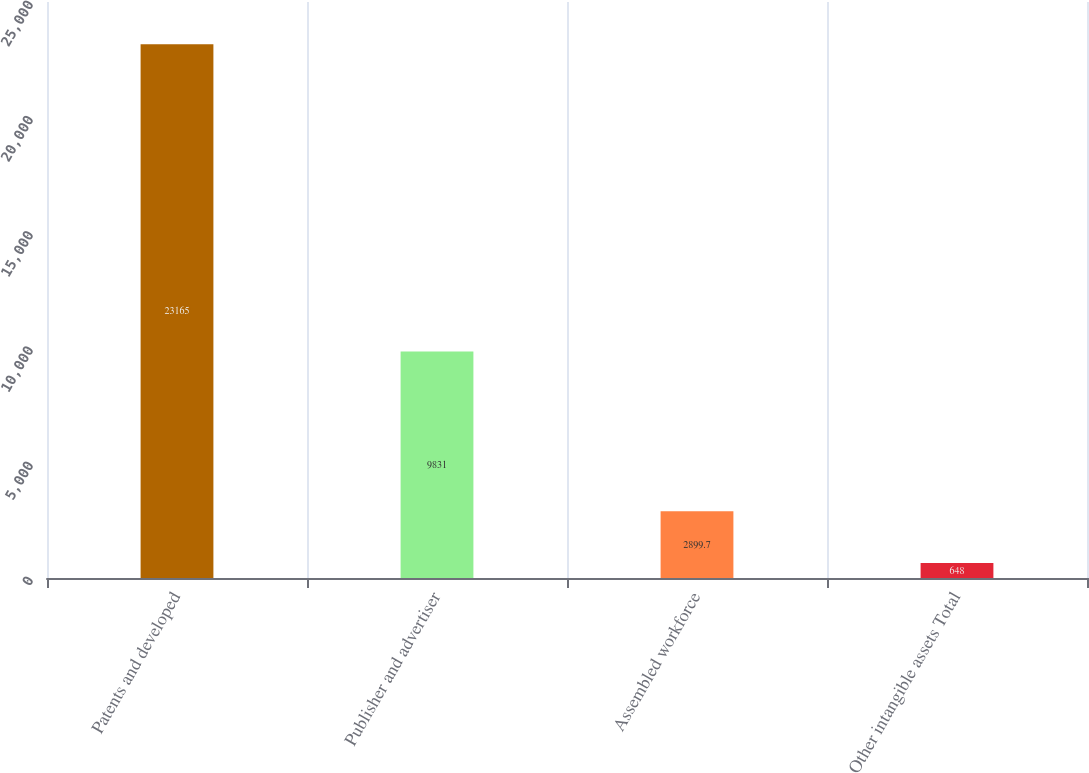Convert chart. <chart><loc_0><loc_0><loc_500><loc_500><bar_chart><fcel>Patents and developed<fcel>Publisher and advertiser<fcel>Assembled workforce<fcel>Other intangible assets Total<nl><fcel>23165<fcel>9831<fcel>2899.7<fcel>648<nl></chart> 